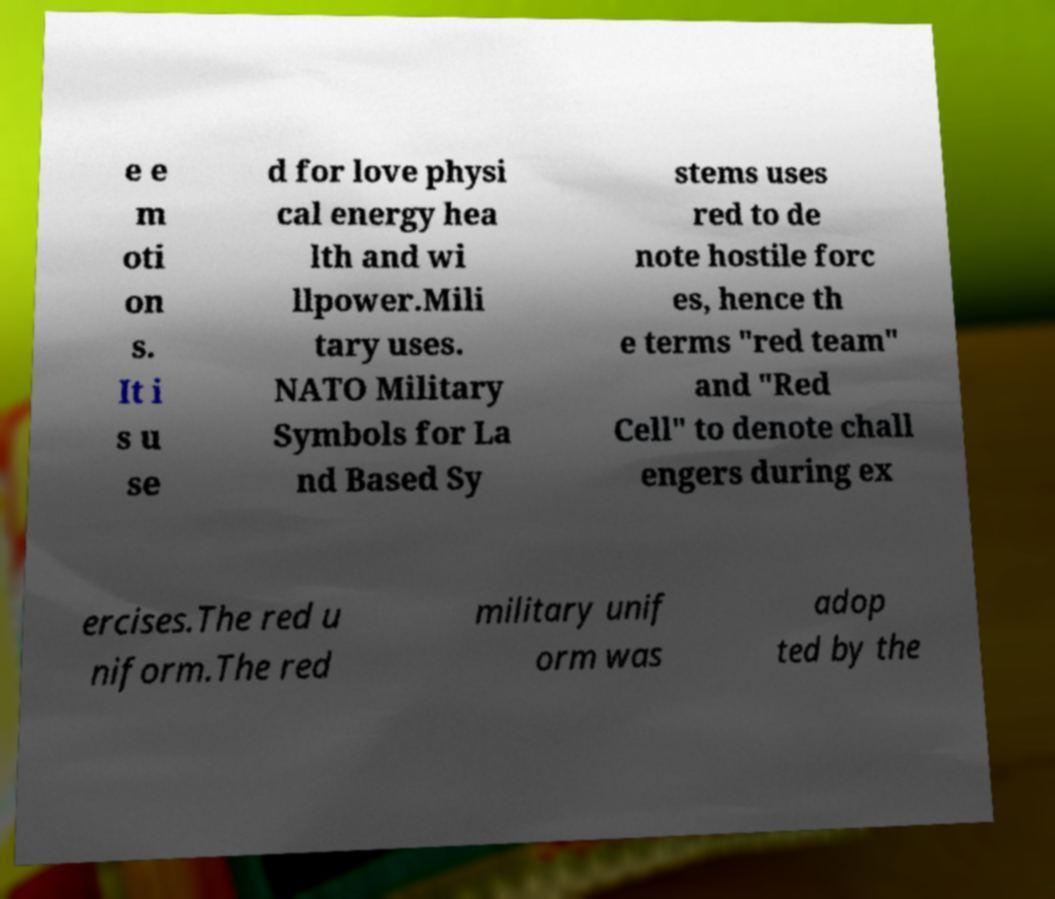Can you read and provide the text displayed in the image?This photo seems to have some interesting text. Can you extract and type it out for me? e e m oti on s. It i s u se d for love physi cal energy hea lth and wi llpower.Mili tary uses. NATO Military Symbols for La nd Based Sy stems uses red to de note hostile forc es, hence th e terms "red team" and "Red Cell" to denote chall engers during ex ercises.The red u niform.The red military unif orm was adop ted by the 